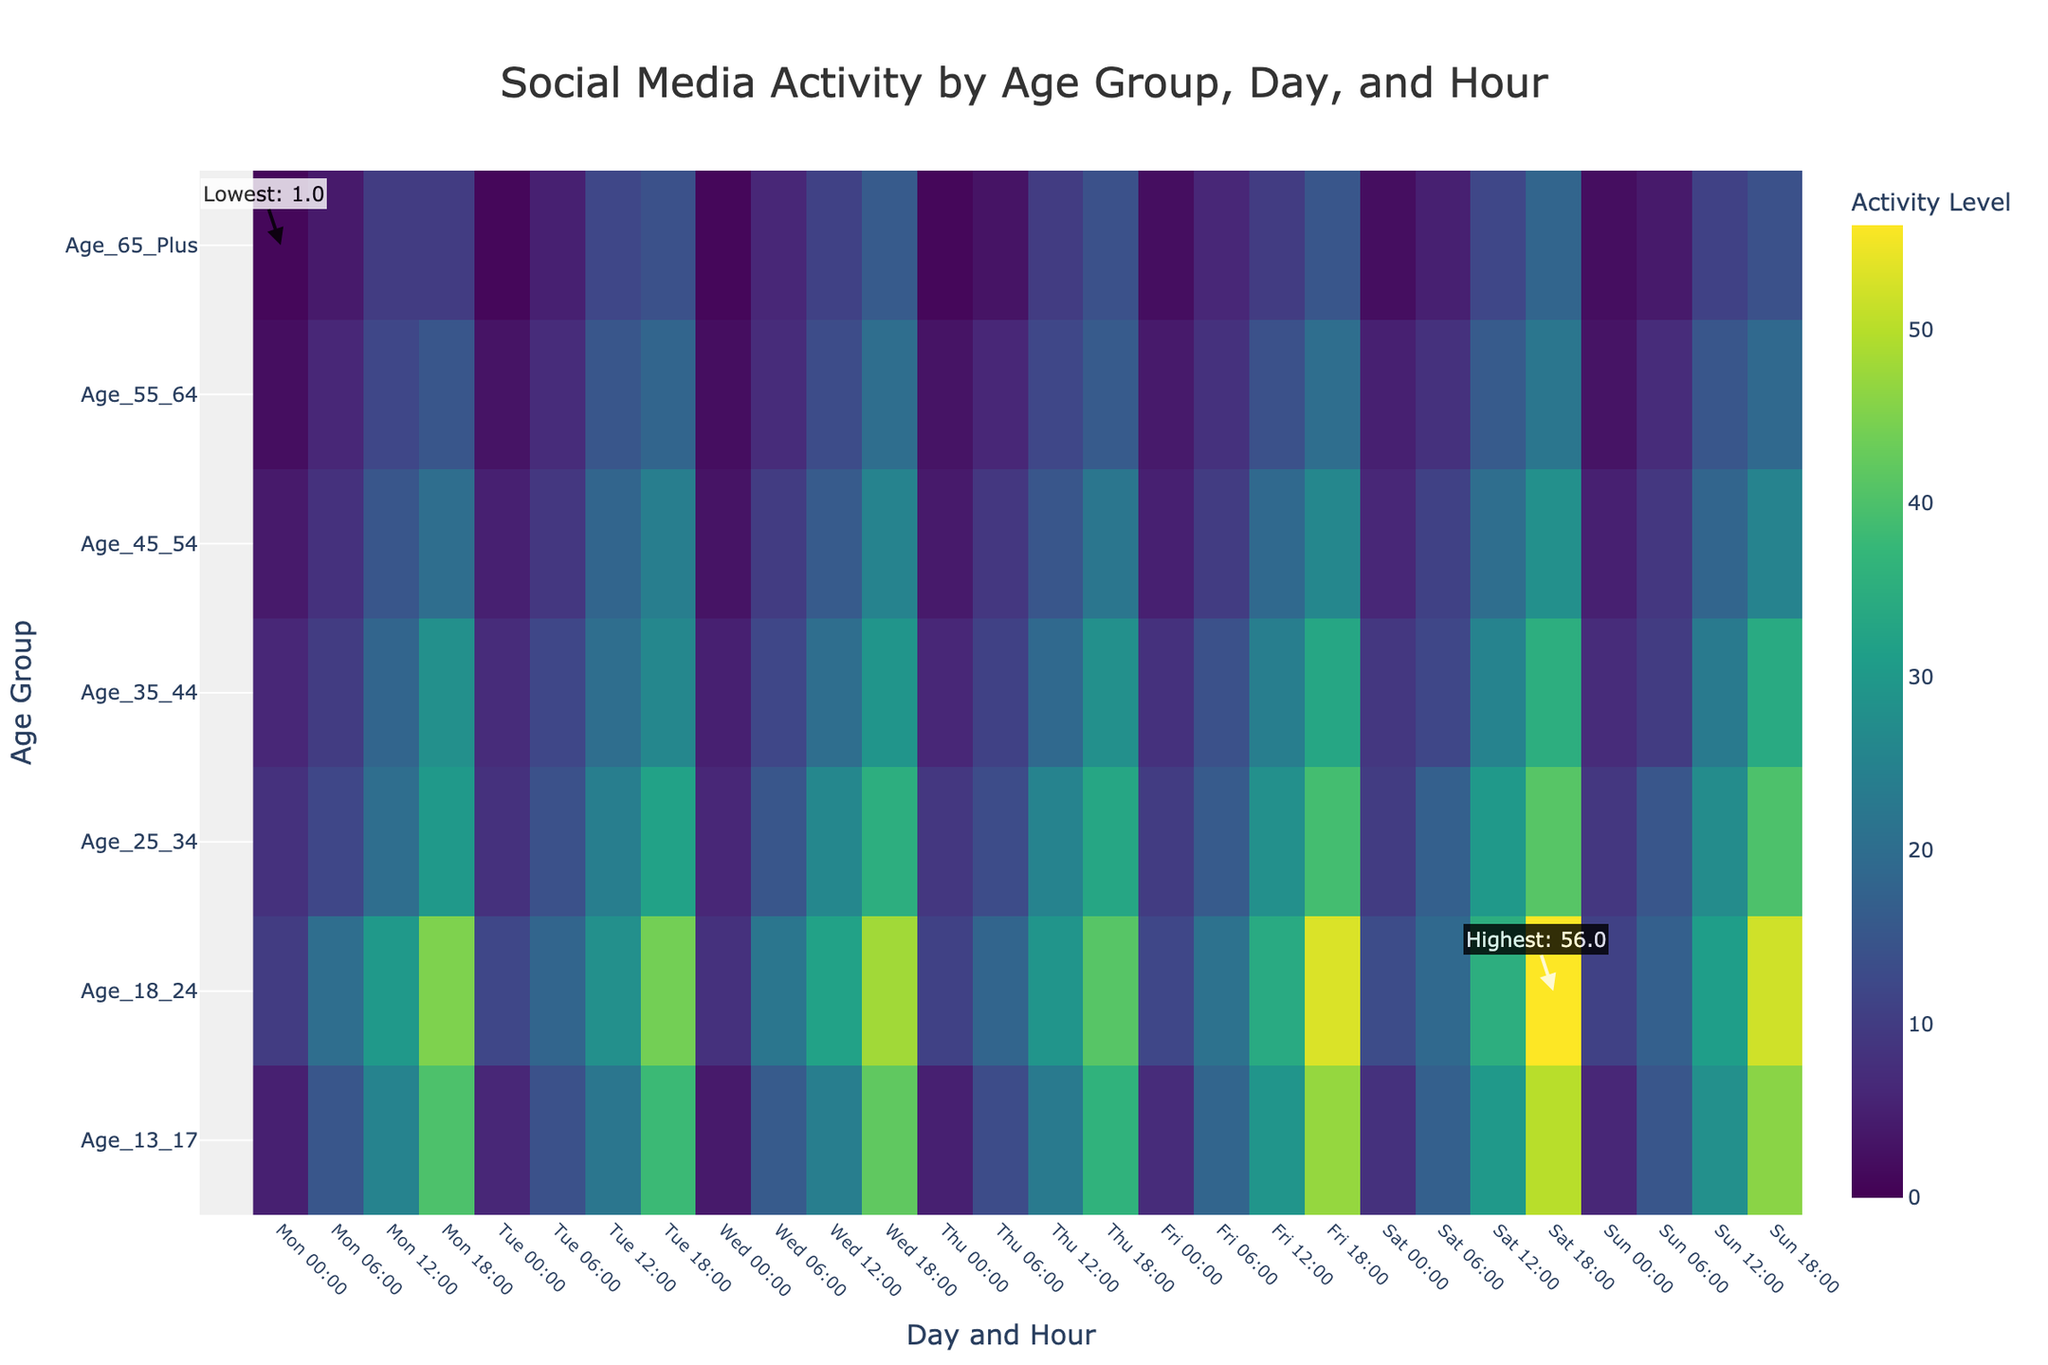Which age group shows the highest social media activity overall? By observing the heatmap, the highest activity levels are consistently represented in the warm colors (yellow and green). The age group 'Age_18_24' frequently reaches the highest values, especially in the evening hours.
Answer: Age_18_24 On which day does the age group 45-54 show the maximum activity? Looking at the annotations and colorful peaks in the heatmap, 'Age_45_54' reaches its highest activity level on Friday at 18:00.
Answer: Friday Which hours show the lowest activity for age group 65 and above throughout the week? The heatmap shows the lowest intensity for 'Age_65_Plus' in most early morning hours (around 0:00), specifically on Monday, Tuesday, and Wednesday, which are annotated in lighter colors.
Answer: Early morning hours (0:00) What is the difference in activity levels between Friday 18:00 and Wednesday 0:00 for the age group 25-34? By checking the heatmap, 'Age_25_34' has an activity level of 39 at Friday 18:00 and 6 at Wednesday 0:00. The difference is calculated as 39 - 6.
Answer: 33 Which age group has the narrowest range of activity levels throughout the week? By examining the variance in color intensities, 'Age_65_Plus' shows the least variation, staying mostly in cooler colors and signifying a narrow range.
Answer: Age_65_Plus On average, are the weekend activity levels higher or lower than weekdays for age group 18-24? Observing the heatmap, the weekend days (Saturday and Sunday) for 'Age_18_24' have consistently high activity values, particularly during evening hours. This suggests an overall higher average on weekends compared to weekdays.
Answer: Higher Which day and time show the highest activity for the 35-44 age group? The heatmap highlights peak activities for 'Age_35_44' on Friday at 18:00, marked by warm colors.
Answer: Friday 18:00 Compare the activity levels between the age groups 13-17 and 25-34 on Thursday at 12:00. Referring to the heatmap, activity level for 'Age_13_17' is 23 and for 'Age_25_34' is 25 on Thursday at 12:00.
Answer: Age_25_34 has higher activity What is the prevalent time of highest activity for most age groups? Most age groups show their peak activities around the 18:00 time slot, indicated by the warmest colors for that hour across various days.
Answer: 18:00 How does the activity level on Sunday 12:00 for age group 55-64 compare to the same time on Friday? The heatmap shows 'Age_55_64' activity at 18 on Sunday 12:00 and 19 on Friday 12:00. Thus, activity is slightly lower on Sunday compared to Friday at this same hour.
Answer: Slightly lower on Sunday 